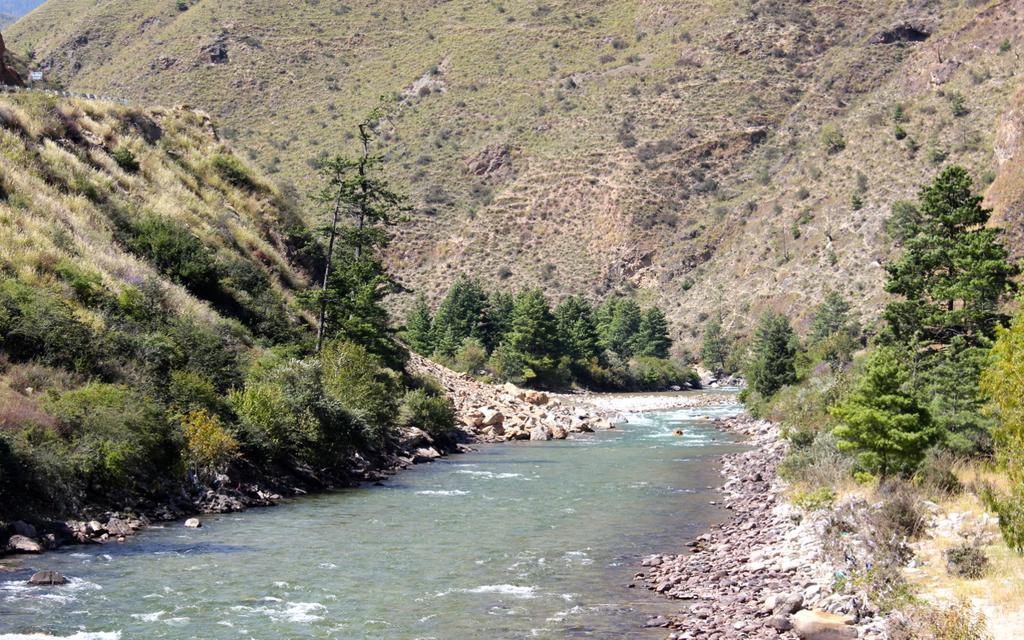Can you describe this image briefly? In this picture there is a mountain and there are trees. At the top left there is a railing and there is a board. At the bottom there is water and there are stones. 